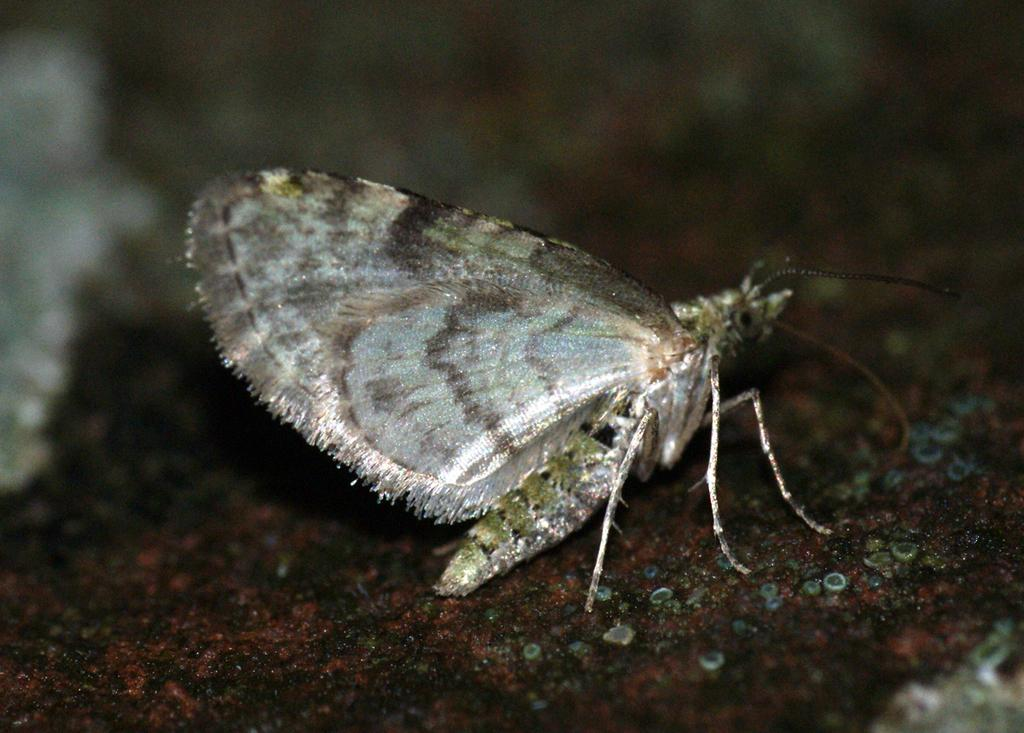What type of creature is in the image? There is an insect in the image. Where is the insect located? The insect is on a platform. Can you describe the background of the image? The background of the image is blurry. What type of apparatus is the insect using to fly in the image? There is no apparatus present in the image; the insect is naturally flying or crawling on the platform. 